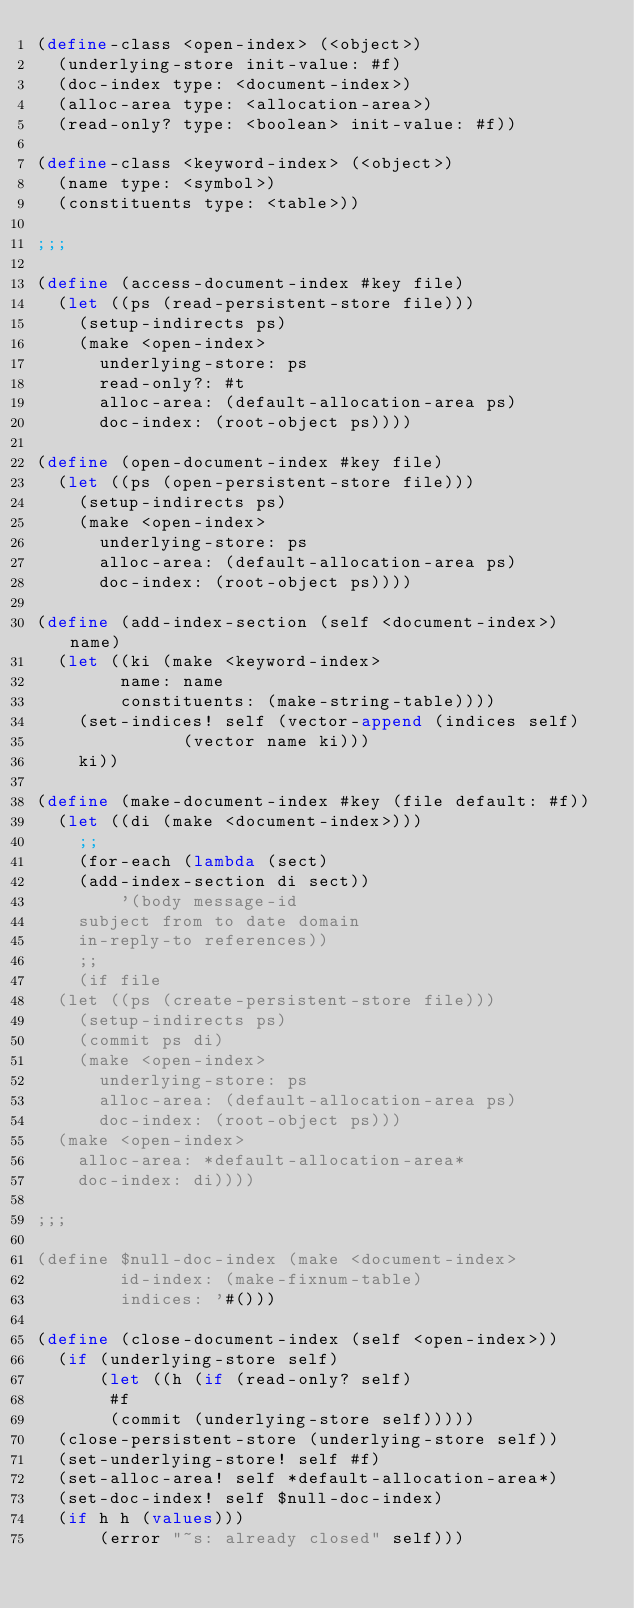<code> <loc_0><loc_0><loc_500><loc_500><_Scheme_>(define-class <open-index> (<object>)
  (underlying-store init-value: #f)
  (doc-index type: <document-index>)
  (alloc-area type: <allocation-area>)
  (read-only? type: <boolean> init-value: #f))

(define-class <keyword-index> (<object>)
  (name type: <symbol>)
  (constituents type: <table>))
			       
;;;

(define (access-document-index #key file)
  (let ((ps (read-persistent-store file)))
    (setup-indirects ps)
    (make <open-index>
      underlying-store: ps
      read-only?: #t
      alloc-area: (default-allocation-area ps)
      doc-index: (root-object ps))))

(define (open-document-index #key file)
  (let ((ps (open-persistent-store file)))
    (setup-indirects ps)
    (make <open-index>
      underlying-store: ps
      alloc-area: (default-allocation-area ps)
      doc-index: (root-object ps))))

(define (add-index-section (self <document-index>) name)
  (let ((ki (make <keyword-index>
	      name: name
	      constituents: (make-string-table))))
    (set-indices! self (vector-append (indices self)
				      (vector name ki)))
    ki))

(define (make-document-index #key (file default: #f))
  (let ((di (make <document-index>)))
    ;;
    (for-each (lambda (sect)
		(add-index-section di sect))
	      '(body message-id
		subject from to date domain
		in-reply-to references))
    ;;
    (if file
	(let ((ps (create-persistent-store file)))
	  (setup-indirects ps)
	  (commit ps di)
	  (make <open-index>
	    underlying-store: ps
	    alloc-area: (default-allocation-area ps)
	    doc-index: (root-object ps)))
	(make <open-index>
	  alloc-area: *default-allocation-area*
	  doc-index: di))))

;;;

(define $null-doc-index (make <document-index>
			  id-index: (make-fixnum-table)
			  indices: '#()))

(define (close-document-index (self <open-index>))
  (if (underlying-store self)
      (let ((h (if (read-only? self)
		   #f
		   (commit (underlying-store self)))))
	(close-persistent-store (underlying-store self))
	(set-underlying-store! self #f)
	(set-alloc-area! self *default-allocation-area*)
	(set-doc-index! self $null-doc-index)
	(if h h (values)))
      (error "~s: already closed" self)))

</code> 